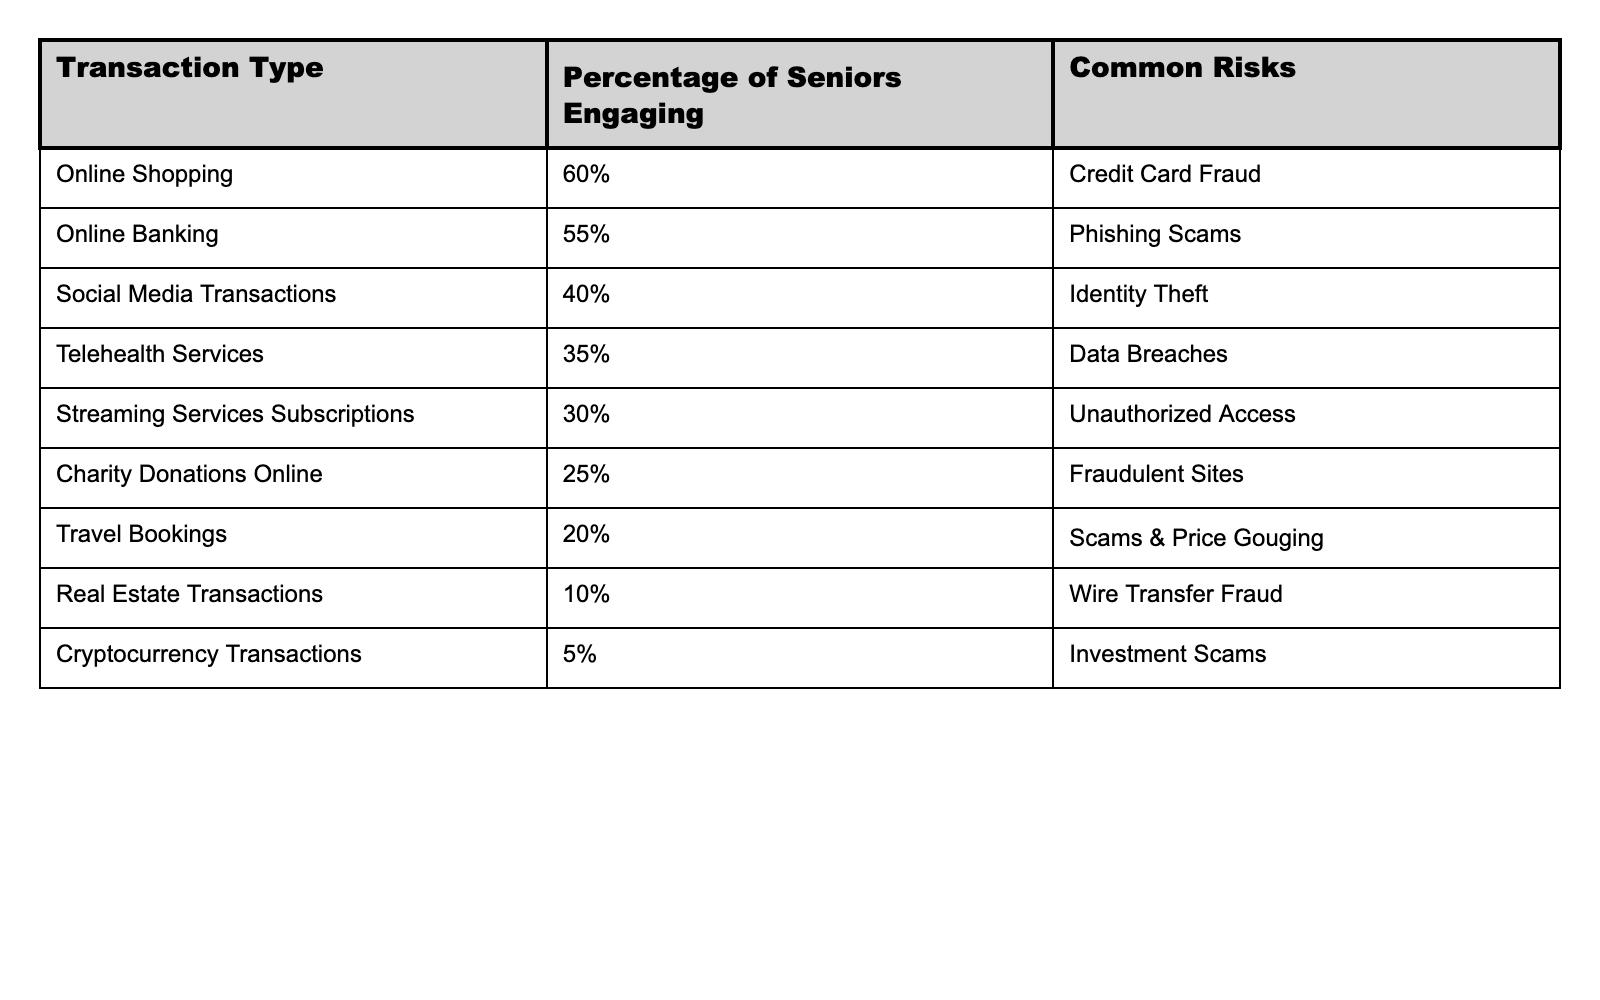What percentage of seniors engage in online shopping? The table shows that 60% of seniors engage in online shopping.
Answer: 60% What is the common risk associated with online banking for seniors? According to the table, the common risk for online banking is phishing scams.
Answer: Phishing scams Which transaction type has the lowest percentage of seniors engaging? The table indicates that cryptocurrency transactions have the lowest percentage at 5%.
Answer: 5% What percentage of seniors engage in travel bookings, and what is the associated risk? The table lists that 20% of seniors engage in travel bookings, and the associated risk is scams and price gouging.
Answer: 20%, scams and price gouging Is identity theft a common risk for telehealth services? The table indicates that the common risk for telehealth services is data breaches, not identity theft.
Answer: No Which two transaction types have the highest participation rates among seniors? By inspecting the table, online shopping (60%) and online banking (55%) have the highest participation rates.
Answer: Online shopping and online banking What is the difference in the percentage of seniors engaging in online shopping and social media transactions? The percentage of seniors engaging in online shopping is 60%, while social media transactions is 40%. Therefore, the difference is 60% - 40% = 20%.
Answer: 20% If we were to average the percentage of seniors engaging in online banking and telehealth services, what would that be? Online banking has 55% participation, and telehealth services have 35%. The average is calculated as (55% + 35%) / 2 = 45%.
Answer: 45% Considering all the transaction types, which one carries the risk of wire transfer fraud? The table specifies that real estate transactions are associated with the risk of wire transfer fraud.
Answer: Real estate transactions What can be said about the overall trend in senior engagement with online transactions and the associated risks? The table shows that as participation decreases, the associated risks vary in severity, indicating that different online transaction types present different security challenges.
Answer: Higher participation may correlate with higher risks 